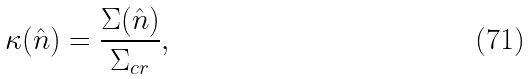Convert formula to latex. <formula><loc_0><loc_0><loc_500><loc_500>\kappa ( \hat { n } ) = \frac { \Sigma ( \hat { n } ) } { \Sigma _ { c r } } ,</formula> 